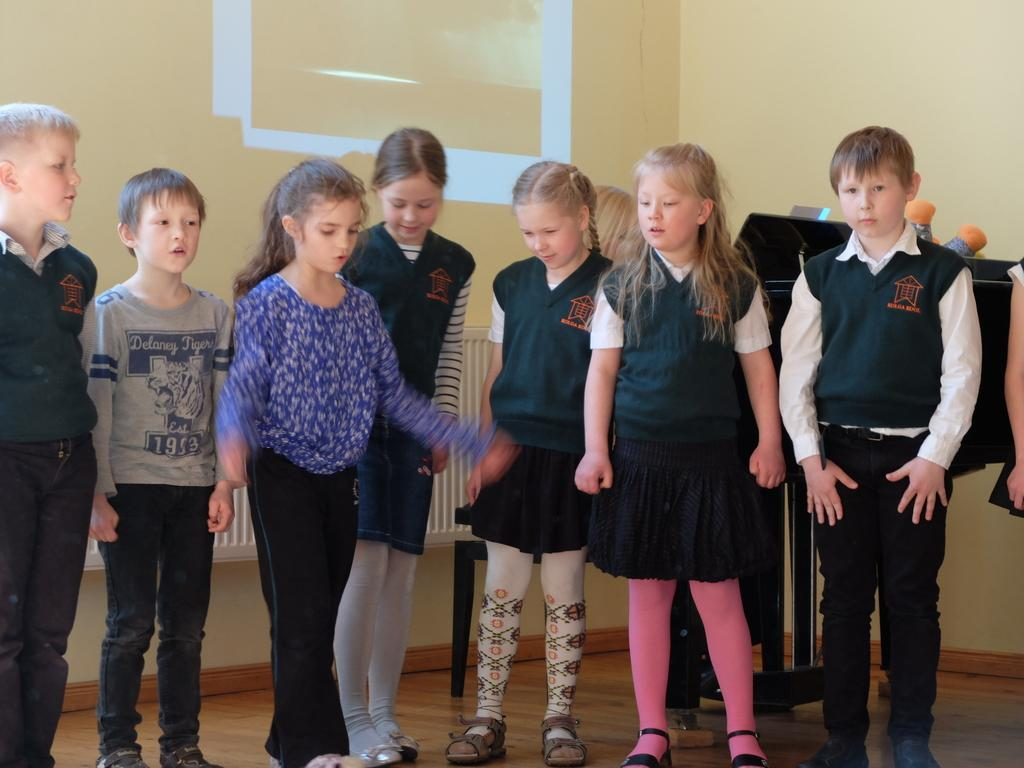What is the main subject of the image? The main subject of the image is a group of kids. What type of surface are the kids standing on? The kids are standing on a wooden floor. What can be seen behind the kids in the image? There are objects visible behind the kids. What is the background of the image? There is a wall in the background of the image. How does the cent express its anger in the image? There is no cent or any indication of anger present in the image. 